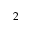<formula> <loc_0><loc_0><loc_500><loc_500>2</formula> 